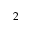<formula> <loc_0><loc_0><loc_500><loc_500>2</formula> 